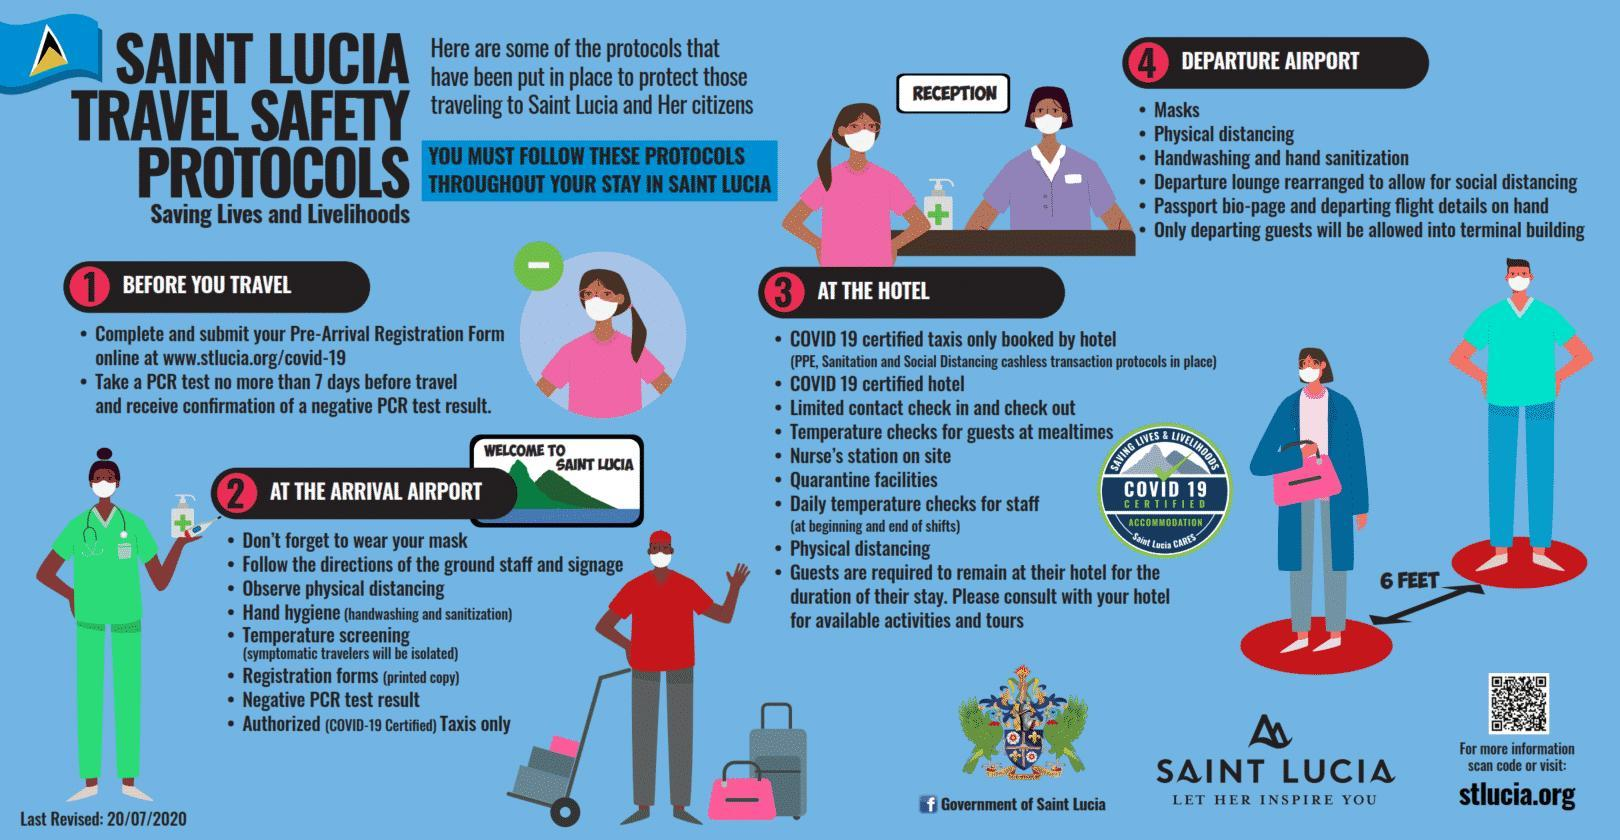What is the distance specified for physical distancing?
Answer the question with a short phrase. 6 FEET How many times has physical/social distancing been mentioned? 4 